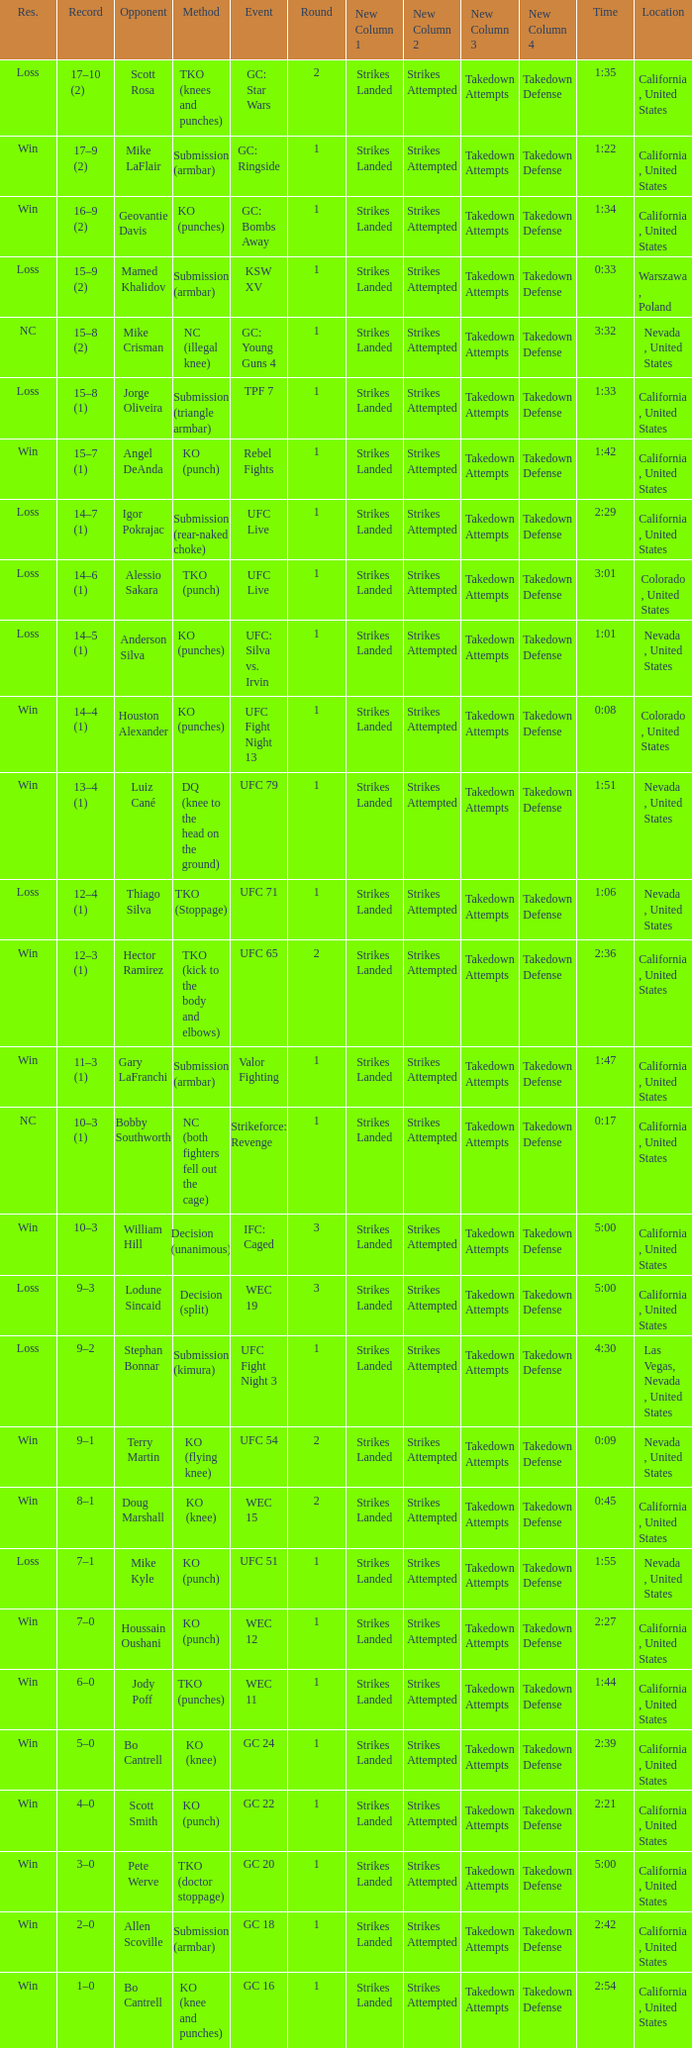What was the method when the time was 1:01? KO (punches). 